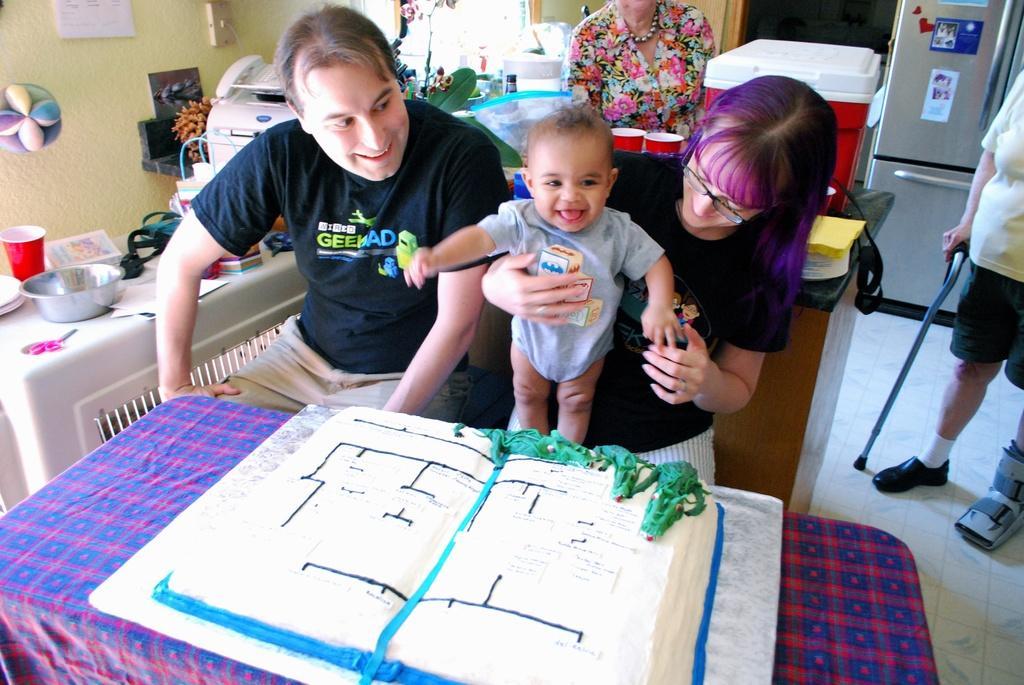Describe this image in one or two sentences. In the image we can see there are people who are sitting on chair and at the back people are standing. On the table there is a cake. 